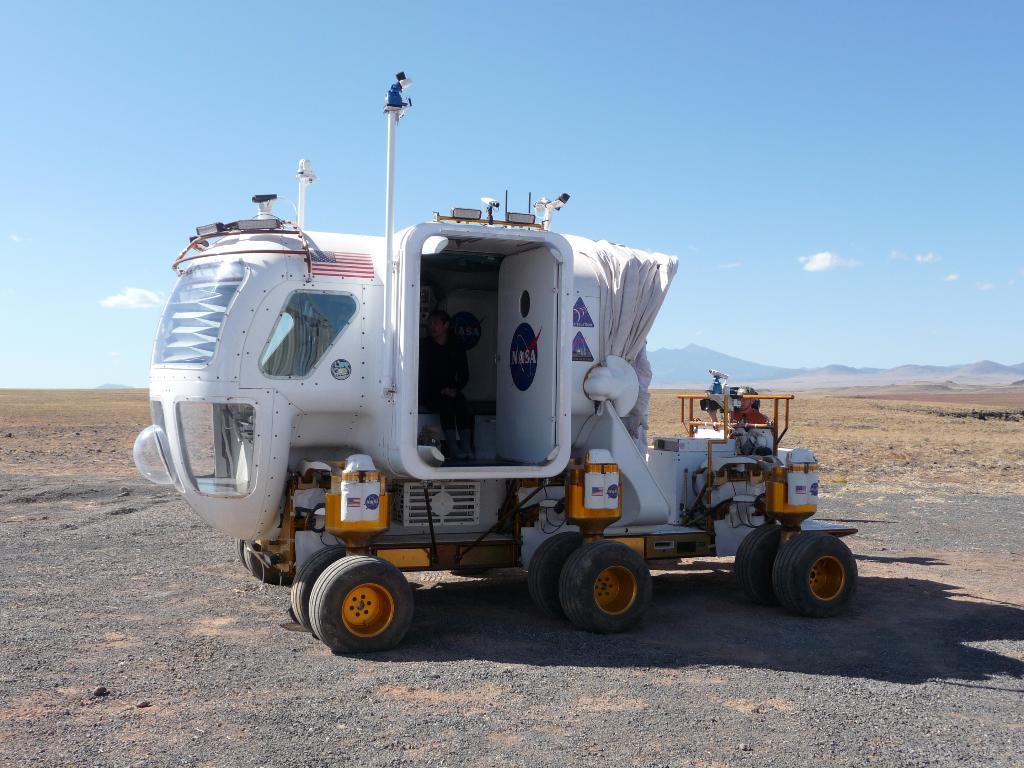Please provide a concise description of this image. In the middle I can see a vehicle on the road and a person. In the background I can see grass, mountains and the sky. This image is taken may be in a farm during a day. 